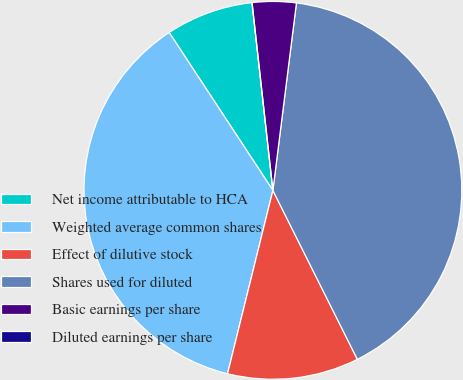Convert chart to OTSL. <chart><loc_0><loc_0><loc_500><loc_500><pie_chart><fcel>Net income attributable to HCA<fcel>Weighted average common shares<fcel>Effect of dilutive stock<fcel>Shares used for diluted<fcel>Basic earnings per share<fcel>Diluted earnings per share<nl><fcel>7.49%<fcel>36.89%<fcel>11.24%<fcel>40.63%<fcel>3.75%<fcel>0.0%<nl></chart> 